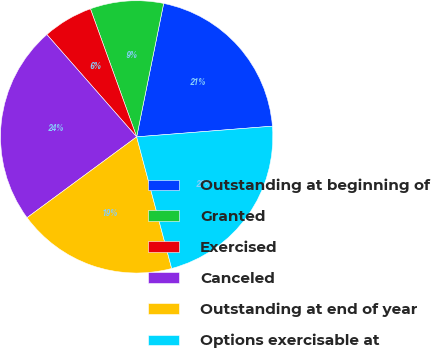Convert chart to OTSL. <chart><loc_0><loc_0><loc_500><loc_500><pie_chart><fcel>Outstanding at beginning of<fcel>Granted<fcel>Exercised<fcel>Canceled<fcel>Outstanding at end of year<fcel>Options exercisable at<nl><fcel>20.57%<fcel>8.69%<fcel>5.95%<fcel>23.64%<fcel>19.03%<fcel>22.11%<nl></chart> 